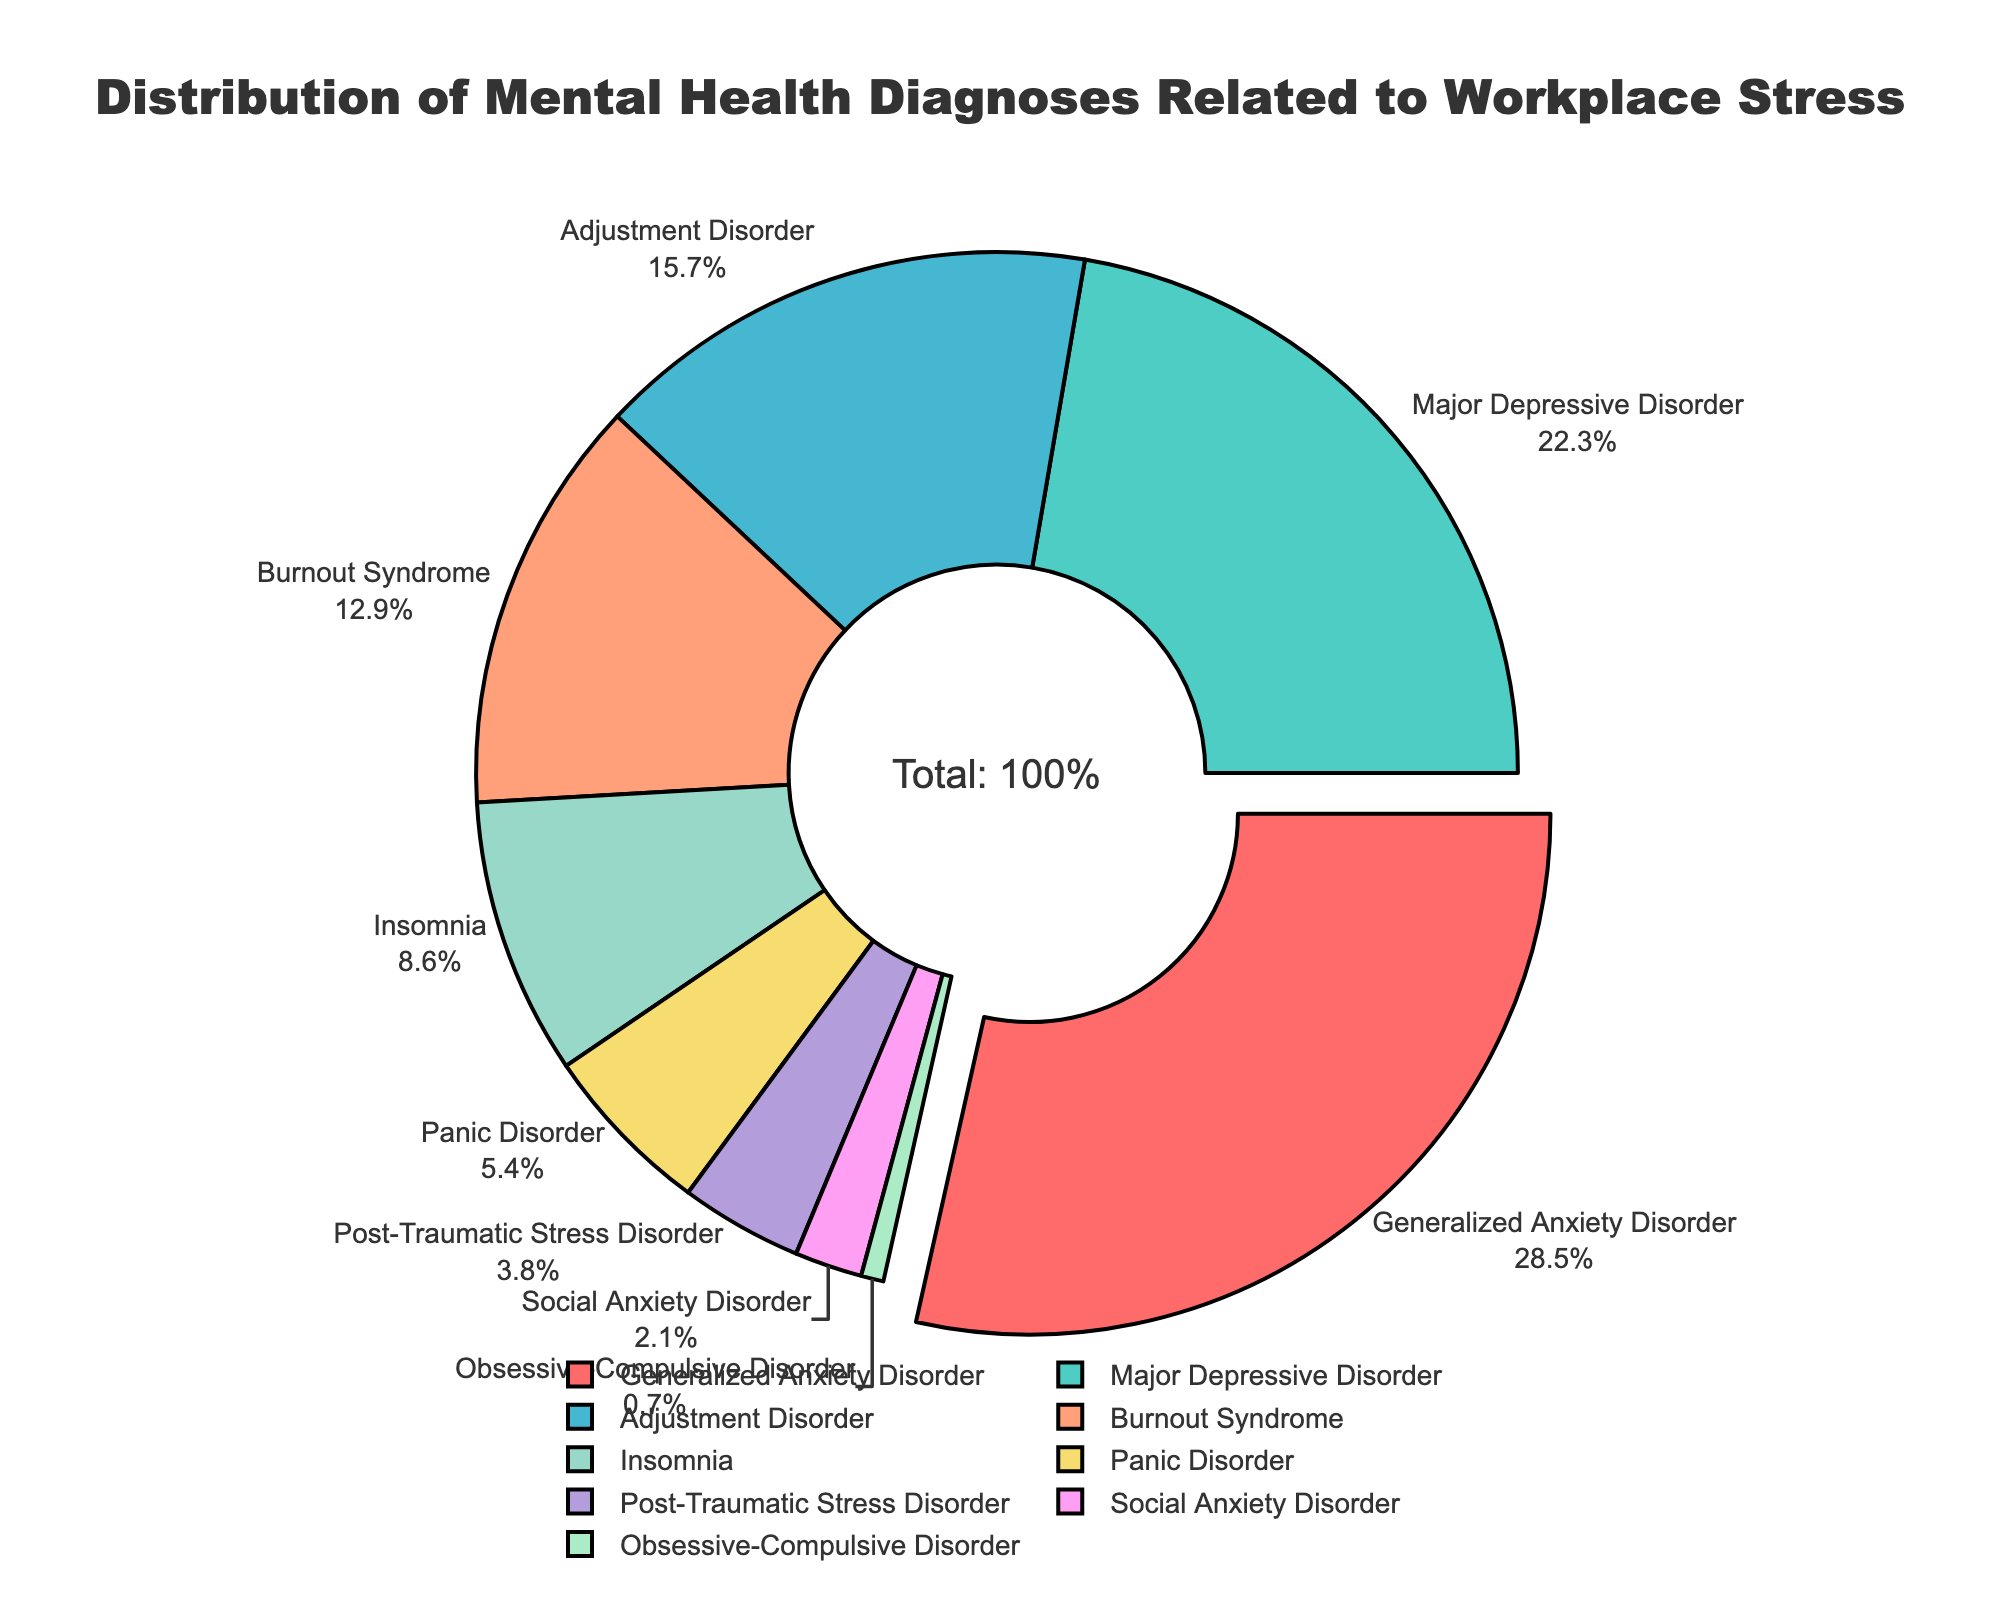What percentage of the diagnoses is Generalized Anxiety Disorder? The slice labeled "Generalized Anxiety Disorder" has a percentage annotation.
Answer: 28.5% What are the two most prevalent diagnoses in the pie chart? By inspecting the pie chart, the largest slices are "Generalized Anxiety Disorder" at 28.5% and "Major Depressive Disorder" at 22.3%.
Answer: Generalized Anxiety Disorder and Major Depressive Disorder Which diagnosis has the smallest percentage? The smallest slice in the pie chart is labeled "Obsessive-Compulsive Disorder."
Answer: Obsessive-Compulsive Disorder How much more prevalent is Generalized Anxiety Disorder compared to Insomnia? Generalized Anxiety Disorder has a percentage of 28.5% and Insomnia has 8.6%. Subtract 8.6% from 28.5%. 28.5% - 8.6% = 19.9%
Answer: 19.9% What is the combined percentage of Adjustment Disorder and Burnout Syndrome? Add the percentages of Adjustment Disorder (15.7%) and Burnout Syndrome (12.9%). 15.7% + 12.9% = 28.6%
Answer: 28.6% Which diagnosis has a proportion that is more than double that of Social Anxiety Disorder? Social Anxiety Disorder is at 2.1%, so look for diagnoses with percentages greater than 4.2%. Generalized Anxiety Disorder (28.5%), Major Depressive Disorder (22.3%), Adjustment Disorder (15.7%), Burnout Syndrome (12.9%), and Insomnia (8.6%) all fit this criterion.
Answer: Generalized Anxiety Disorder, Major Depressive Disorder, Adjustment Disorder, Burnout Syndrome, Insomnia Is the percentage of Major Depressive Disorder about the same or significantly different from Panic Disorder? Major Depressive Disorder is 22.3% while Panic Disorder is 5.4%. The difference is 22.3% - 5.4% = 16.9%, which is significant.
Answer: Significantly different What diagnosis has a similar prevalence to Panic Disorder? Inspect the slices and note that Panic Disorder is 5.4%, and the closest percentage is Post-Traumatic Stress Disorder at 3.8%. However, none have the same value, just similar.
Answer: None What is the visual distinction made for the diagnosis with the highest percentage? The slice for "Generalized Anxiety Disorder" is pulled out slightly from the pie, making it visually distinguishable.
Answer: It's pulled out Which diagnosis percentages add up to just over 50%? Adding up Generalized Anxiety Disorder (28.5%) and Major Depressive Disorder (22.3%) gives a total of 50.8%.
Answer: Generalized Anxiety Disorder and Major Depressive Disorder 